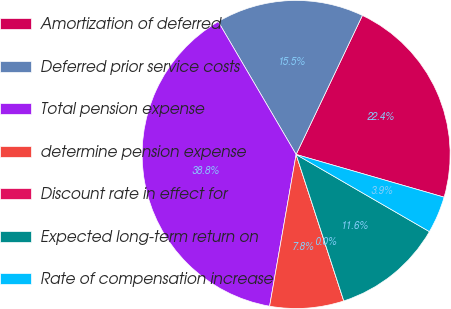Convert chart to OTSL. <chart><loc_0><loc_0><loc_500><loc_500><pie_chart><fcel>Amortization of deferred<fcel>Deferred prior service costs<fcel>Total pension expense<fcel>determine pension expense<fcel>Discount rate in effect for<fcel>Expected long-term return on<fcel>Rate of compensation increase<nl><fcel>22.39%<fcel>15.52%<fcel>38.8%<fcel>7.76%<fcel>0.0%<fcel>11.64%<fcel>3.88%<nl></chart> 